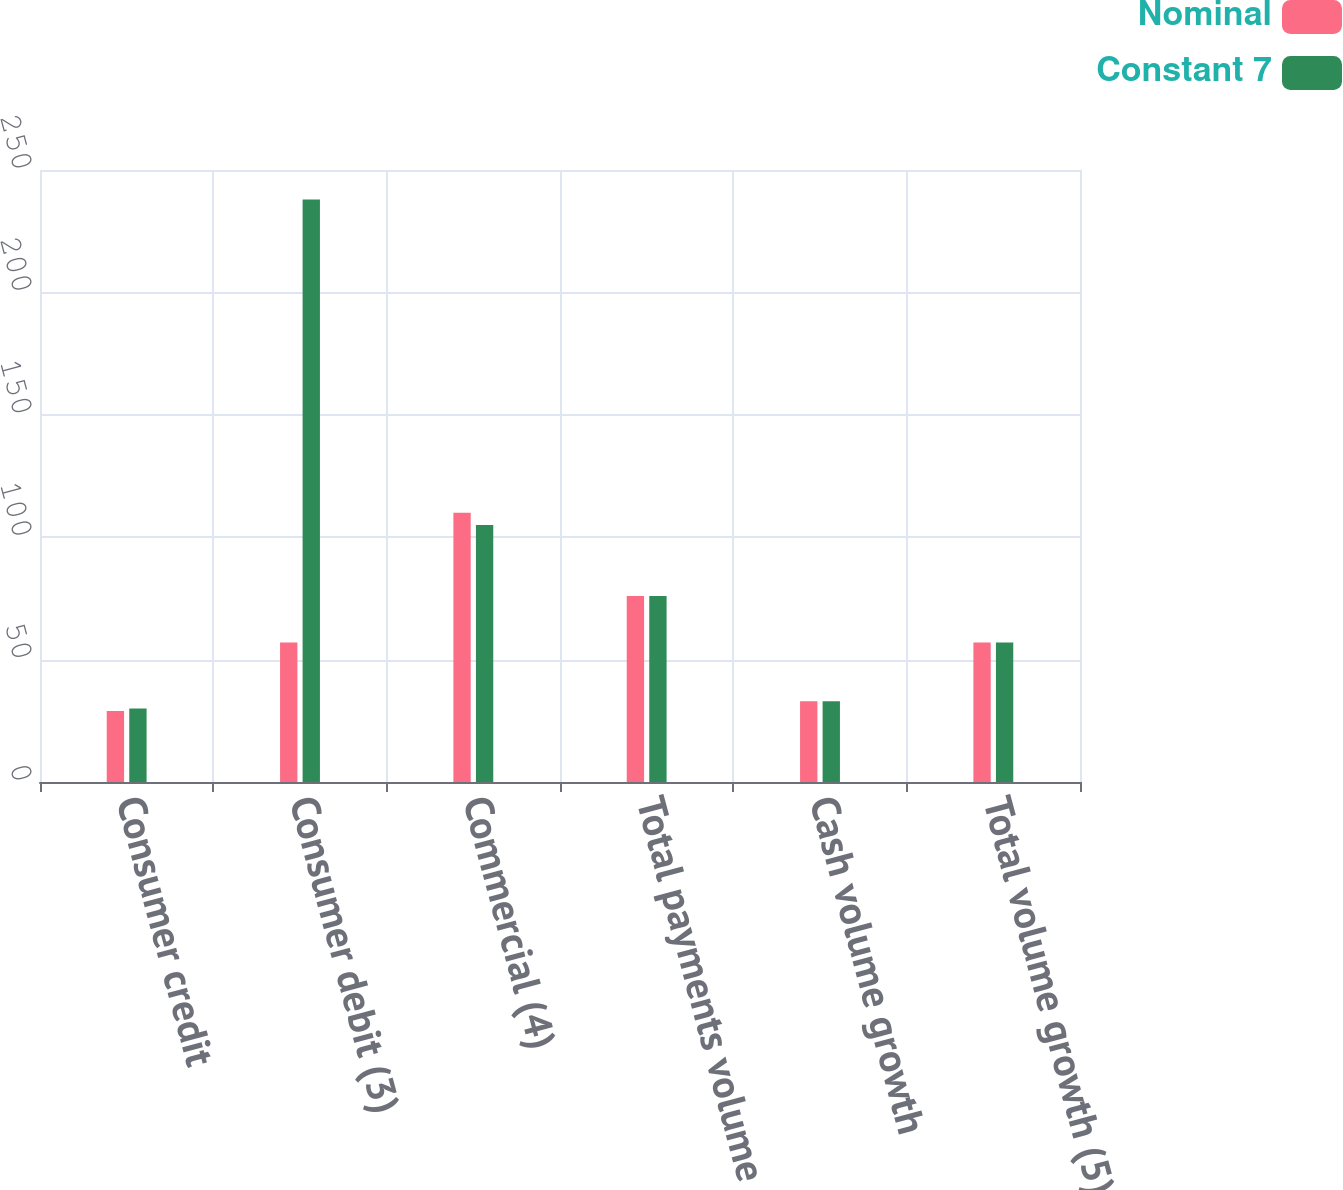Convert chart. <chart><loc_0><loc_0><loc_500><loc_500><stacked_bar_chart><ecel><fcel>Consumer credit<fcel>Consumer debit (3)<fcel>Commercial (4)<fcel>Total payments volume growth<fcel>Cash volume growth<fcel>Total volume growth (5)<nl><fcel>Nominal<fcel>29<fcel>57<fcel>110<fcel>76<fcel>33<fcel>57<nl><fcel>Constant 7<fcel>30<fcel>238<fcel>105<fcel>76<fcel>33<fcel>57<nl></chart> 